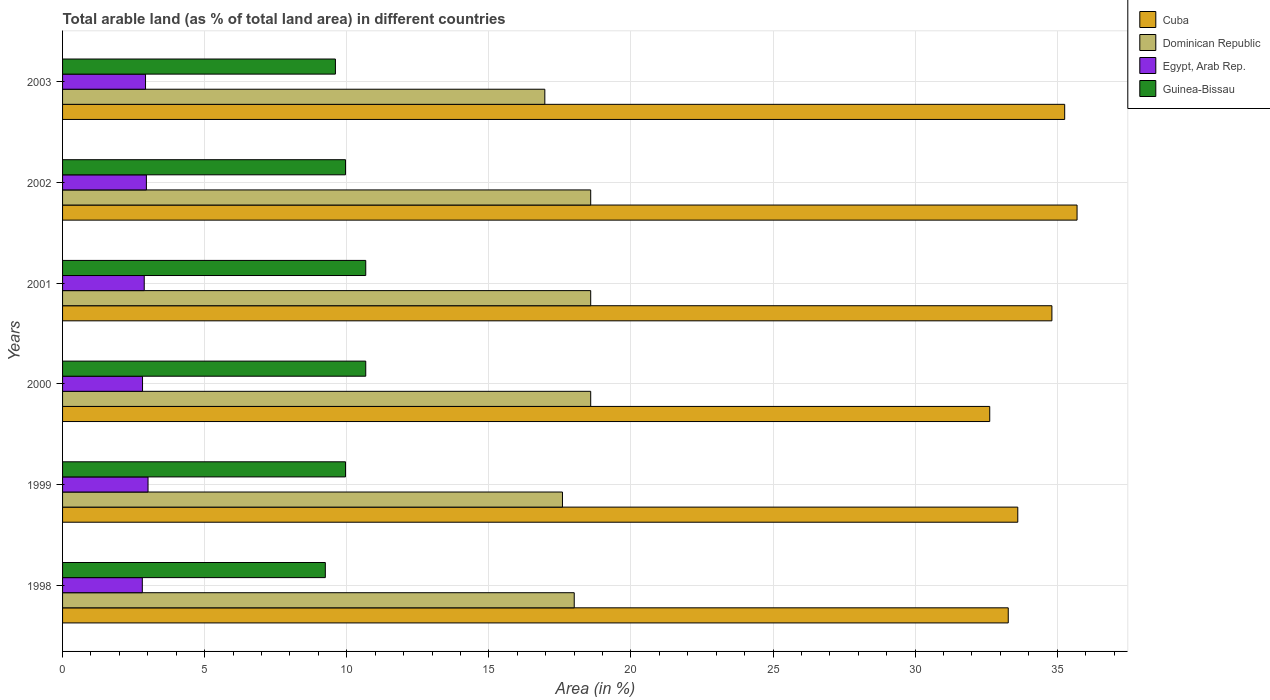Are the number of bars on each tick of the Y-axis equal?
Your answer should be compact. Yes. In how many cases, is the number of bars for a given year not equal to the number of legend labels?
Give a very brief answer. 0. What is the percentage of arable land in Guinea-Bissau in 1999?
Your answer should be compact. 9.96. Across all years, what is the maximum percentage of arable land in Egypt, Arab Rep.?
Offer a very short reply. 3.01. Across all years, what is the minimum percentage of arable land in Cuba?
Make the answer very short. 32.63. In which year was the percentage of arable land in Egypt, Arab Rep. maximum?
Give a very brief answer. 1999. What is the total percentage of arable land in Guinea-Bissau in the graph?
Your response must be concise. 60.1. What is the difference between the percentage of arable land in Dominican Republic in 2001 and that in 2003?
Make the answer very short. 1.61. What is the difference between the percentage of arable land in Egypt, Arab Rep. in 1998 and the percentage of arable land in Dominican Republic in 1999?
Give a very brief answer. -14.78. What is the average percentage of arable land in Dominican Republic per year?
Offer a terse response. 18.05. In the year 2002, what is the difference between the percentage of arable land in Egypt, Arab Rep. and percentage of arable land in Cuba?
Ensure brevity in your answer.  -32.75. What is the ratio of the percentage of arable land in Dominican Republic in 1998 to that in 2002?
Give a very brief answer. 0.97. Is the percentage of arable land in Dominican Republic in 1998 less than that in 2000?
Give a very brief answer. Yes. Is the difference between the percentage of arable land in Egypt, Arab Rep. in 1999 and 2001 greater than the difference between the percentage of arable land in Cuba in 1999 and 2001?
Provide a short and direct response. Yes. What is the difference between the highest and the lowest percentage of arable land in Guinea-Bissau?
Give a very brief answer. 1.42. In how many years, is the percentage of arable land in Egypt, Arab Rep. greater than the average percentage of arable land in Egypt, Arab Rep. taken over all years?
Offer a terse response. 3. Is the sum of the percentage of arable land in Dominican Republic in 2001 and 2002 greater than the maximum percentage of arable land in Egypt, Arab Rep. across all years?
Give a very brief answer. Yes. Is it the case that in every year, the sum of the percentage of arable land in Dominican Republic and percentage of arable land in Guinea-Bissau is greater than the sum of percentage of arable land in Egypt, Arab Rep. and percentage of arable land in Cuba?
Offer a very short reply. No. What does the 1st bar from the top in 1998 represents?
Provide a short and direct response. Guinea-Bissau. What does the 2nd bar from the bottom in 2000 represents?
Provide a succinct answer. Dominican Republic. Is it the case that in every year, the sum of the percentage of arable land in Egypt, Arab Rep. and percentage of arable land in Cuba is greater than the percentage of arable land in Guinea-Bissau?
Give a very brief answer. Yes. Are all the bars in the graph horizontal?
Keep it short and to the point. Yes. Where does the legend appear in the graph?
Make the answer very short. Top right. How many legend labels are there?
Provide a succinct answer. 4. How are the legend labels stacked?
Give a very brief answer. Vertical. What is the title of the graph?
Your response must be concise. Total arable land (as % of total land area) in different countries. Does "Central Europe" appear as one of the legend labels in the graph?
Give a very brief answer. No. What is the label or title of the X-axis?
Your answer should be very brief. Area (in %). What is the label or title of the Y-axis?
Give a very brief answer. Years. What is the Area (in %) of Cuba in 1998?
Offer a very short reply. 33.28. What is the Area (in %) in Dominican Republic in 1998?
Keep it short and to the point. 18. What is the Area (in %) in Egypt, Arab Rep. in 1998?
Keep it short and to the point. 2.81. What is the Area (in %) in Guinea-Bissau in 1998?
Provide a succinct answer. 9.25. What is the Area (in %) in Cuba in 1999?
Give a very brief answer. 33.61. What is the Area (in %) in Dominican Republic in 1999?
Provide a succinct answer. 17.59. What is the Area (in %) in Egypt, Arab Rep. in 1999?
Your answer should be very brief. 3.01. What is the Area (in %) in Guinea-Bissau in 1999?
Your response must be concise. 9.96. What is the Area (in %) of Cuba in 2000?
Give a very brief answer. 32.63. What is the Area (in %) of Dominican Republic in 2000?
Keep it short and to the point. 18.58. What is the Area (in %) in Egypt, Arab Rep. in 2000?
Provide a short and direct response. 2.81. What is the Area (in %) in Guinea-Bissau in 2000?
Your answer should be compact. 10.67. What is the Area (in %) of Cuba in 2001?
Offer a terse response. 34.81. What is the Area (in %) of Dominican Republic in 2001?
Offer a terse response. 18.58. What is the Area (in %) in Egypt, Arab Rep. in 2001?
Your answer should be compact. 2.87. What is the Area (in %) of Guinea-Bissau in 2001?
Make the answer very short. 10.67. What is the Area (in %) in Cuba in 2002?
Your answer should be compact. 35.7. What is the Area (in %) in Dominican Republic in 2002?
Give a very brief answer. 18.58. What is the Area (in %) in Egypt, Arab Rep. in 2002?
Provide a short and direct response. 2.95. What is the Area (in %) of Guinea-Bissau in 2002?
Make the answer very short. 9.96. What is the Area (in %) in Cuba in 2003?
Make the answer very short. 35.26. What is the Area (in %) of Dominican Republic in 2003?
Make the answer very short. 16.97. What is the Area (in %) in Egypt, Arab Rep. in 2003?
Offer a terse response. 2.92. What is the Area (in %) of Guinea-Bissau in 2003?
Your answer should be compact. 9.6. Across all years, what is the maximum Area (in %) of Cuba?
Your answer should be compact. 35.7. Across all years, what is the maximum Area (in %) of Dominican Republic?
Make the answer very short. 18.58. Across all years, what is the maximum Area (in %) of Egypt, Arab Rep.?
Your answer should be very brief. 3.01. Across all years, what is the maximum Area (in %) in Guinea-Bissau?
Ensure brevity in your answer.  10.67. Across all years, what is the minimum Area (in %) in Cuba?
Give a very brief answer. 32.63. Across all years, what is the minimum Area (in %) in Dominican Republic?
Your response must be concise. 16.97. Across all years, what is the minimum Area (in %) in Egypt, Arab Rep.?
Give a very brief answer. 2.81. Across all years, what is the minimum Area (in %) in Guinea-Bissau?
Your answer should be compact. 9.25. What is the total Area (in %) in Cuba in the graph?
Provide a succinct answer. 205.29. What is the total Area (in %) of Dominican Republic in the graph?
Keep it short and to the point. 108.32. What is the total Area (in %) of Egypt, Arab Rep. in the graph?
Your answer should be compact. 17.37. What is the total Area (in %) of Guinea-Bissau in the graph?
Give a very brief answer. 60.1. What is the difference between the Area (in %) of Cuba in 1998 and that in 1999?
Make the answer very short. -0.34. What is the difference between the Area (in %) in Dominican Republic in 1998 and that in 1999?
Keep it short and to the point. 0.41. What is the difference between the Area (in %) of Egypt, Arab Rep. in 1998 and that in 1999?
Keep it short and to the point. -0.2. What is the difference between the Area (in %) of Guinea-Bissau in 1998 and that in 1999?
Keep it short and to the point. -0.71. What is the difference between the Area (in %) in Cuba in 1998 and that in 2000?
Your response must be concise. 0.65. What is the difference between the Area (in %) in Dominican Republic in 1998 and that in 2000?
Offer a terse response. -0.58. What is the difference between the Area (in %) of Egypt, Arab Rep. in 1998 and that in 2000?
Ensure brevity in your answer.  -0.01. What is the difference between the Area (in %) in Guinea-Bissau in 1998 and that in 2000?
Offer a terse response. -1.42. What is the difference between the Area (in %) of Cuba in 1998 and that in 2001?
Offer a very short reply. -1.54. What is the difference between the Area (in %) of Dominican Republic in 1998 and that in 2001?
Offer a very short reply. -0.58. What is the difference between the Area (in %) in Egypt, Arab Rep. in 1998 and that in 2001?
Ensure brevity in your answer.  -0.07. What is the difference between the Area (in %) of Guinea-Bissau in 1998 and that in 2001?
Make the answer very short. -1.42. What is the difference between the Area (in %) in Cuba in 1998 and that in 2002?
Give a very brief answer. -2.42. What is the difference between the Area (in %) in Dominican Republic in 1998 and that in 2002?
Provide a succinct answer. -0.58. What is the difference between the Area (in %) in Egypt, Arab Rep. in 1998 and that in 2002?
Give a very brief answer. -0.14. What is the difference between the Area (in %) in Guinea-Bissau in 1998 and that in 2002?
Your answer should be compact. -0.71. What is the difference between the Area (in %) of Cuba in 1998 and that in 2003?
Ensure brevity in your answer.  -1.99. What is the difference between the Area (in %) in Dominican Republic in 1998 and that in 2003?
Give a very brief answer. 1.03. What is the difference between the Area (in %) of Egypt, Arab Rep. in 1998 and that in 2003?
Offer a terse response. -0.11. What is the difference between the Area (in %) in Guinea-Bissau in 1998 and that in 2003?
Ensure brevity in your answer.  -0.36. What is the difference between the Area (in %) of Cuba in 1999 and that in 2000?
Ensure brevity in your answer.  0.99. What is the difference between the Area (in %) in Dominican Republic in 1999 and that in 2000?
Your response must be concise. -0.99. What is the difference between the Area (in %) of Egypt, Arab Rep. in 1999 and that in 2000?
Offer a very short reply. 0.19. What is the difference between the Area (in %) in Guinea-Bissau in 1999 and that in 2000?
Offer a very short reply. -0.71. What is the difference between the Area (in %) in Cuba in 1999 and that in 2001?
Ensure brevity in your answer.  -1.2. What is the difference between the Area (in %) in Dominican Republic in 1999 and that in 2001?
Your answer should be very brief. -0.99. What is the difference between the Area (in %) in Egypt, Arab Rep. in 1999 and that in 2001?
Offer a terse response. 0.13. What is the difference between the Area (in %) in Guinea-Bissau in 1999 and that in 2001?
Keep it short and to the point. -0.71. What is the difference between the Area (in %) of Cuba in 1999 and that in 2002?
Keep it short and to the point. -2.09. What is the difference between the Area (in %) in Dominican Republic in 1999 and that in 2002?
Offer a terse response. -0.99. What is the difference between the Area (in %) in Egypt, Arab Rep. in 1999 and that in 2002?
Offer a very short reply. 0.06. What is the difference between the Area (in %) of Guinea-Bissau in 1999 and that in 2002?
Your answer should be compact. 0. What is the difference between the Area (in %) of Cuba in 1999 and that in 2003?
Provide a short and direct response. -1.65. What is the difference between the Area (in %) of Dominican Republic in 1999 and that in 2003?
Provide a succinct answer. 0.62. What is the difference between the Area (in %) in Egypt, Arab Rep. in 1999 and that in 2003?
Offer a terse response. 0.09. What is the difference between the Area (in %) in Guinea-Bissau in 1999 and that in 2003?
Give a very brief answer. 0.36. What is the difference between the Area (in %) of Cuba in 2000 and that in 2001?
Make the answer very short. -2.19. What is the difference between the Area (in %) of Dominican Republic in 2000 and that in 2001?
Your response must be concise. 0. What is the difference between the Area (in %) of Egypt, Arab Rep. in 2000 and that in 2001?
Ensure brevity in your answer.  -0.06. What is the difference between the Area (in %) of Guinea-Bissau in 2000 and that in 2001?
Make the answer very short. 0. What is the difference between the Area (in %) in Cuba in 2000 and that in 2002?
Keep it short and to the point. -3.07. What is the difference between the Area (in %) in Egypt, Arab Rep. in 2000 and that in 2002?
Give a very brief answer. -0.14. What is the difference between the Area (in %) in Guinea-Bissau in 2000 and that in 2002?
Provide a succinct answer. 0.71. What is the difference between the Area (in %) in Cuba in 2000 and that in 2003?
Your answer should be very brief. -2.64. What is the difference between the Area (in %) of Dominican Republic in 2000 and that in 2003?
Your answer should be very brief. 1.61. What is the difference between the Area (in %) of Egypt, Arab Rep. in 2000 and that in 2003?
Keep it short and to the point. -0.11. What is the difference between the Area (in %) of Guinea-Bissau in 2000 and that in 2003?
Offer a terse response. 1.07. What is the difference between the Area (in %) of Cuba in 2001 and that in 2002?
Provide a succinct answer. -0.89. What is the difference between the Area (in %) in Egypt, Arab Rep. in 2001 and that in 2002?
Offer a very short reply. -0.08. What is the difference between the Area (in %) of Guinea-Bissau in 2001 and that in 2002?
Your answer should be compact. 0.71. What is the difference between the Area (in %) of Cuba in 2001 and that in 2003?
Provide a succinct answer. -0.45. What is the difference between the Area (in %) of Dominican Republic in 2001 and that in 2003?
Your response must be concise. 1.61. What is the difference between the Area (in %) in Egypt, Arab Rep. in 2001 and that in 2003?
Offer a very short reply. -0.05. What is the difference between the Area (in %) in Guinea-Bissau in 2001 and that in 2003?
Your answer should be very brief. 1.07. What is the difference between the Area (in %) of Cuba in 2002 and that in 2003?
Keep it short and to the point. 0.44. What is the difference between the Area (in %) of Dominican Republic in 2002 and that in 2003?
Make the answer very short. 1.61. What is the difference between the Area (in %) of Egypt, Arab Rep. in 2002 and that in 2003?
Make the answer very short. 0.03. What is the difference between the Area (in %) in Guinea-Bissau in 2002 and that in 2003?
Ensure brevity in your answer.  0.36. What is the difference between the Area (in %) of Cuba in 1998 and the Area (in %) of Dominican Republic in 1999?
Ensure brevity in your answer.  15.69. What is the difference between the Area (in %) of Cuba in 1998 and the Area (in %) of Egypt, Arab Rep. in 1999?
Provide a succinct answer. 30.27. What is the difference between the Area (in %) of Cuba in 1998 and the Area (in %) of Guinea-Bissau in 1999?
Make the answer very short. 23.32. What is the difference between the Area (in %) in Dominican Republic in 1998 and the Area (in %) in Egypt, Arab Rep. in 1999?
Offer a terse response. 15. What is the difference between the Area (in %) in Dominican Republic in 1998 and the Area (in %) in Guinea-Bissau in 1999?
Offer a terse response. 8.05. What is the difference between the Area (in %) in Egypt, Arab Rep. in 1998 and the Area (in %) in Guinea-Bissau in 1999?
Ensure brevity in your answer.  -7.15. What is the difference between the Area (in %) of Cuba in 1998 and the Area (in %) of Dominican Republic in 2000?
Offer a terse response. 14.69. What is the difference between the Area (in %) of Cuba in 1998 and the Area (in %) of Egypt, Arab Rep. in 2000?
Your answer should be compact. 30.46. What is the difference between the Area (in %) in Cuba in 1998 and the Area (in %) in Guinea-Bissau in 2000?
Provide a succinct answer. 22.61. What is the difference between the Area (in %) of Dominican Republic in 1998 and the Area (in %) of Egypt, Arab Rep. in 2000?
Ensure brevity in your answer.  15.19. What is the difference between the Area (in %) of Dominican Republic in 1998 and the Area (in %) of Guinea-Bissau in 2000?
Make the answer very short. 7.34. What is the difference between the Area (in %) in Egypt, Arab Rep. in 1998 and the Area (in %) in Guinea-Bissau in 2000?
Provide a short and direct response. -7.86. What is the difference between the Area (in %) in Cuba in 1998 and the Area (in %) in Dominican Republic in 2001?
Offer a terse response. 14.69. What is the difference between the Area (in %) in Cuba in 1998 and the Area (in %) in Egypt, Arab Rep. in 2001?
Offer a terse response. 30.4. What is the difference between the Area (in %) in Cuba in 1998 and the Area (in %) in Guinea-Bissau in 2001?
Provide a short and direct response. 22.61. What is the difference between the Area (in %) in Dominican Republic in 1998 and the Area (in %) in Egypt, Arab Rep. in 2001?
Make the answer very short. 15.13. What is the difference between the Area (in %) in Dominican Republic in 1998 and the Area (in %) in Guinea-Bissau in 2001?
Give a very brief answer. 7.34. What is the difference between the Area (in %) of Egypt, Arab Rep. in 1998 and the Area (in %) of Guinea-Bissau in 2001?
Provide a succinct answer. -7.86. What is the difference between the Area (in %) of Cuba in 1998 and the Area (in %) of Dominican Republic in 2002?
Give a very brief answer. 14.69. What is the difference between the Area (in %) of Cuba in 1998 and the Area (in %) of Egypt, Arab Rep. in 2002?
Your answer should be compact. 30.33. What is the difference between the Area (in %) in Cuba in 1998 and the Area (in %) in Guinea-Bissau in 2002?
Your answer should be compact. 23.32. What is the difference between the Area (in %) of Dominican Republic in 1998 and the Area (in %) of Egypt, Arab Rep. in 2002?
Ensure brevity in your answer.  15.06. What is the difference between the Area (in %) in Dominican Republic in 1998 and the Area (in %) in Guinea-Bissau in 2002?
Make the answer very short. 8.05. What is the difference between the Area (in %) of Egypt, Arab Rep. in 1998 and the Area (in %) of Guinea-Bissau in 2002?
Give a very brief answer. -7.15. What is the difference between the Area (in %) in Cuba in 1998 and the Area (in %) in Dominican Republic in 2003?
Keep it short and to the point. 16.31. What is the difference between the Area (in %) of Cuba in 1998 and the Area (in %) of Egypt, Arab Rep. in 2003?
Keep it short and to the point. 30.36. What is the difference between the Area (in %) in Cuba in 1998 and the Area (in %) in Guinea-Bissau in 2003?
Offer a terse response. 23.68. What is the difference between the Area (in %) of Dominican Republic in 1998 and the Area (in %) of Egypt, Arab Rep. in 2003?
Your response must be concise. 15.09. What is the difference between the Area (in %) of Dominican Republic in 1998 and the Area (in %) of Guinea-Bissau in 2003?
Offer a terse response. 8.4. What is the difference between the Area (in %) in Egypt, Arab Rep. in 1998 and the Area (in %) in Guinea-Bissau in 2003?
Make the answer very short. -6.8. What is the difference between the Area (in %) of Cuba in 1999 and the Area (in %) of Dominican Republic in 2000?
Make the answer very short. 15.03. What is the difference between the Area (in %) of Cuba in 1999 and the Area (in %) of Egypt, Arab Rep. in 2000?
Your answer should be compact. 30.8. What is the difference between the Area (in %) of Cuba in 1999 and the Area (in %) of Guinea-Bissau in 2000?
Give a very brief answer. 22.94. What is the difference between the Area (in %) in Dominican Republic in 1999 and the Area (in %) in Egypt, Arab Rep. in 2000?
Make the answer very short. 14.78. What is the difference between the Area (in %) of Dominican Republic in 1999 and the Area (in %) of Guinea-Bissau in 2000?
Your answer should be very brief. 6.92. What is the difference between the Area (in %) of Egypt, Arab Rep. in 1999 and the Area (in %) of Guinea-Bissau in 2000?
Your response must be concise. -7.66. What is the difference between the Area (in %) in Cuba in 1999 and the Area (in %) in Dominican Republic in 2001?
Your response must be concise. 15.03. What is the difference between the Area (in %) in Cuba in 1999 and the Area (in %) in Egypt, Arab Rep. in 2001?
Your answer should be very brief. 30.74. What is the difference between the Area (in %) of Cuba in 1999 and the Area (in %) of Guinea-Bissau in 2001?
Your answer should be compact. 22.94. What is the difference between the Area (in %) of Dominican Republic in 1999 and the Area (in %) of Egypt, Arab Rep. in 2001?
Your answer should be compact. 14.72. What is the difference between the Area (in %) of Dominican Republic in 1999 and the Area (in %) of Guinea-Bissau in 2001?
Your answer should be very brief. 6.92. What is the difference between the Area (in %) of Egypt, Arab Rep. in 1999 and the Area (in %) of Guinea-Bissau in 2001?
Give a very brief answer. -7.66. What is the difference between the Area (in %) in Cuba in 1999 and the Area (in %) in Dominican Republic in 2002?
Ensure brevity in your answer.  15.03. What is the difference between the Area (in %) in Cuba in 1999 and the Area (in %) in Egypt, Arab Rep. in 2002?
Offer a very short reply. 30.66. What is the difference between the Area (in %) in Cuba in 1999 and the Area (in %) in Guinea-Bissau in 2002?
Your response must be concise. 23.66. What is the difference between the Area (in %) in Dominican Republic in 1999 and the Area (in %) in Egypt, Arab Rep. in 2002?
Make the answer very short. 14.64. What is the difference between the Area (in %) of Dominican Republic in 1999 and the Area (in %) of Guinea-Bissau in 2002?
Make the answer very short. 7.63. What is the difference between the Area (in %) of Egypt, Arab Rep. in 1999 and the Area (in %) of Guinea-Bissau in 2002?
Provide a succinct answer. -6.95. What is the difference between the Area (in %) of Cuba in 1999 and the Area (in %) of Dominican Republic in 2003?
Provide a short and direct response. 16.64. What is the difference between the Area (in %) of Cuba in 1999 and the Area (in %) of Egypt, Arab Rep. in 2003?
Your answer should be compact. 30.69. What is the difference between the Area (in %) of Cuba in 1999 and the Area (in %) of Guinea-Bissau in 2003?
Provide a succinct answer. 24.01. What is the difference between the Area (in %) in Dominican Republic in 1999 and the Area (in %) in Egypt, Arab Rep. in 2003?
Your answer should be compact. 14.67. What is the difference between the Area (in %) of Dominican Republic in 1999 and the Area (in %) of Guinea-Bissau in 2003?
Ensure brevity in your answer.  7.99. What is the difference between the Area (in %) of Egypt, Arab Rep. in 1999 and the Area (in %) of Guinea-Bissau in 2003?
Make the answer very short. -6.59. What is the difference between the Area (in %) of Cuba in 2000 and the Area (in %) of Dominican Republic in 2001?
Offer a very short reply. 14.04. What is the difference between the Area (in %) of Cuba in 2000 and the Area (in %) of Egypt, Arab Rep. in 2001?
Offer a very short reply. 29.75. What is the difference between the Area (in %) of Cuba in 2000 and the Area (in %) of Guinea-Bissau in 2001?
Offer a terse response. 21.96. What is the difference between the Area (in %) of Dominican Republic in 2000 and the Area (in %) of Egypt, Arab Rep. in 2001?
Keep it short and to the point. 15.71. What is the difference between the Area (in %) in Dominican Republic in 2000 and the Area (in %) in Guinea-Bissau in 2001?
Your response must be concise. 7.92. What is the difference between the Area (in %) in Egypt, Arab Rep. in 2000 and the Area (in %) in Guinea-Bissau in 2001?
Your response must be concise. -7.85. What is the difference between the Area (in %) in Cuba in 2000 and the Area (in %) in Dominican Republic in 2002?
Provide a succinct answer. 14.04. What is the difference between the Area (in %) in Cuba in 2000 and the Area (in %) in Egypt, Arab Rep. in 2002?
Your answer should be compact. 29.68. What is the difference between the Area (in %) in Cuba in 2000 and the Area (in %) in Guinea-Bissau in 2002?
Provide a short and direct response. 22.67. What is the difference between the Area (in %) of Dominican Republic in 2000 and the Area (in %) of Egypt, Arab Rep. in 2002?
Provide a succinct answer. 15.63. What is the difference between the Area (in %) in Dominican Republic in 2000 and the Area (in %) in Guinea-Bissau in 2002?
Keep it short and to the point. 8.63. What is the difference between the Area (in %) of Egypt, Arab Rep. in 2000 and the Area (in %) of Guinea-Bissau in 2002?
Give a very brief answer. -7.14. What is the difference between the Area (in %) of Cuba in 2000 and the Area (in %) of Dominican Republic in 2003?
Offer a very short reply. 15.66. What is the difference between the Area (in %) in Cuba in 2000 and the Area (in %) in Egypt, Arab Rep. in 2003?
Make the answer very short. 29.71. What is the difference between the Area (in %) in Cuba in 2000 and the Area (in %) in Guinea-Bissau in 2003?
Make the answer very short. 23.02. What is the difference between the Area (in %) of Dominican Republic in 2000 and the Area (in %) of Egypt, Arab Rep. in 2003?
Give a very brief answer. 15.67. What is the difference between the Area (in %) in Dominican Republic in 2000 and the Area (in %) in Guinea-Bissau in 2003?
Make the answer very short. 8.98. What is the difference between the Area (in %) of Egypt, Arab Rep. in 2000 and the Area (in %) of Guinea-Bissau in 2003?
Offer a very short reply. -6.79. What is the difference between the Area (in %) of Cuba in 2001 and the Area (in %) of Dominican Republic in 2002?
Your response must be concise. 16.23. What is the difference between the Area (in %) of Cuba in 2001 and the Area (in %) of Egypt, Arab Rep. in 2002?
Your answer should be very brief. 31.86. What is the difference between the Area (in %) in Cuba in 2001 and the Area (in %) in Guinea-Bissau in 2002?
Your response must be concise. 24.86. What is the difference between the Area (in %) in Dominican Republic in 2001 and the Area (in %) in Egypt, Arab Rep. in 2002?
Offer a very short reply. 15.63. What is the difference between the Area (in %) in Dominican Republic in 2001 and the Area (in %) in Guinea-Bissau in 2002?
Make the answer very short. 8.63. What is the difference between the Area (in %) of Egypt, Arab Rep. in 2001 and the Area (in %) of Guinea-Bissau in 2002?
Keep it short and to the point. -7.08. What is the difference between the Area (in %) in Cuba in 2001 and the Area (in %) in Dominican Republic in 2003?
Offer a very short reply. 17.84. What is the difference between the Area (in %) of Cuba in 2001 and the Area (in %) of Egypt, Arab Rep. in 2003?
Ensure brevity in your answer.  31.89. What is the difference between the Area (in %) in Cuba in 2001 and the Area (in %) in Guinea-Bissau in 2003?
Offer a very short reply. 25.21. What is the difference between the Area (in %) of Dominican Republic in 2001 and the Area (in %) of Egypt, Arab Rep. in 2003?
Your response must be concise. 15.67. What is the difference between the Area (in %) of Dominican Republic in 2001 and the Area (in %) of Guinea-Bissau in 2003?
Your answer should be very brief. 8.98. What is the difference between the Area (in %) of Egypt, Arab Rep. in 2001 and the Area (in %) of Guinea-Bissau in 2003?
Offer a very short reply. -6.73. What is the difference between the Area (in %) of Cuba in 2002 and the Area (in %) of Dominican Republic in 2003?
Your answer should be compact. 18.73. What is the difference between the Area (in %) in Cuba in 2002 and the Area (in %) in Egypt, Arab Rep. in 2003?
Provide a succinct answer. 32.78. What is the difference between the Area (in %) in Cuba in 2002 and the Area (in %) in Guinea-Bissau in 2003?
Provide a succinct answer. 26.1. What is the difference between the Area (in %) of Dominican Republic in 2002 and the Area (in %) of Egypt, Arab Rep. in 2003?
Your answer should be very brief. 15.67. What is the difference between the Area (in %) of Dominican Republic in 2002 and the Area (in %) of Guinea-Bissau in 2003?
Make the answer very short. 8.98. What is the difference between the Area (in %) of Egypt, Arab Rep. in 2002 and the Area (in %) of Guinea-Bissau in 2003?
Offer a terse response. -6.65. What is the average Area (in %) in Cuba per year?
Give a very brief answer. 34.22. What is the average Area (in %) of Dominican Republic per year?
Provide a succinct answer. 18.05. What is the average Area (in %) in Egypt, Arab Rep. per year?
Keep it short and to the point. 2.9. What is the average Area (in %) in Guinea-Bissau per year?
Offer a very short reply. 10.02. In the year 1998, what is the difference between the Area (in %) in Cuba and Area (in %) in Dominican Republic?
Your answer should be very brief. 15.27. In the year 1998, what is the difference between the Area (in %) in Cuba and Area (in %) in Egypt, Arab Rep.?
Offer a terse response. 30.47. In the year 1998, what is the difference between the Area (in %) of Cuba and Area (in %) of Guinea-Bissau?
Your response must be concise. 24.03. In the year 1998, what is the difference between the Area (in %) of Dominican Republic and Area (in %) of Egypt, Arab Rep.?
Keep it short and to the point. 15.2. In the year 1998, what is the difference between the Area (in %) in Dominican Republic and Area (in %) in Guinea-Bissau?
Ensure brevity in your answer.  8.76. In the year 1998, what is the difference between the Area (in %) in Egypt, Arab Rep. and Area (in %) in Guinea-Bissau?
Provide a short and direct response. -6.44. In the year 1999, what is the difference between the Area (in %) in Cuba and Area (in %) in Dominican Republic?
Your answer should be compact. 16.02. In the year 1999, what is the difference between the Area (in %) in Cuba and Area (in %) in Egypt, Arab Rep.?
Give a very brief answer. 30.61. In the year 1999, what is the difference between the Area (in %) of Cuba and Area (in %) of Guinea-Bissau?
Give a very brief answer. 23.66. In the year 1999, what is the difference between the Area (in %) in Dominican Republic and Area (in %) in Egypt, Arab Rep.?
Offer a terse response. 14.58. In the year 1999, what is the difference between the Area (in %) of Dominican Republic and Area (in %) of Guinea-Bissau?
Offer a terse response. 7.63. In the year 1999, what is the difference between the Area (in %) in Egypt, Arab Rep. and Area (in %) in Guinea-Bissau?
Make the answer very short. -6.95. In the year 2000, what is the difference between the Area (in %) of Cuba and Area (in %) of Dominican Republic?
Offer a very short reply. 14.04. In the year 2000, what is the difference between the Area (in %) in Cuba and Area (in %) in Egypt, Arab Rep.?
Provide a succinct answer. 29.81. In the year 2000, what is the difference between the Area (in %) of Cuba and Area (in %) of Guinea-Bissau?
Make the answer very short. 21.96. In the year 2000, what is the difference between the Area (in %) in Dominican Republic and Area (in %) in Egypt, Arab Rep.?
Ensure brevity in your answer.  15.77. In the year 2000, what is the difference between the Area (in %) in Dominican Republic and Area (in %) in Guinea-Bissau?
Your answer should be compact. 7.92. In the year 2000, what is the difference between the Area (in %) in Egypt, Arab Rep. and Area (in %) in Guinea-Bissau?
Your answer should be very brief. -7.85. In the year 2001, what is the difference between the Area (in %) in Cuba and Area (in %) in Dominican Republic?
Your answer should be compact. 16.23. In the year 2001, what is the difference between the Area (in %) in Cuba and Area (in %) in Egypt, Arab Rep.?
Offer a terse response. 31.94. In the year 2001, what is the difference between the Area (in %) of Cuba and Area (in %) of Guinea-Bissau?
Ensure brevity in your answer.  24.15. In the year 2001, what is the difference between the Area (in %) of Dominican Republic and Area (in %) of Egypt, Arab Rep.?
Keep it short and to the point. 15.71. In the year 2001, what is the difference between the Area (in %) of Dominican Republic and Area (in %) of Guinea-Bissau?
Your response must be concise. 7.92. In the year 2001, what is the difference between the Area (in %) in Egypt, Arab Rep. and Area (in %) in Guinea-Bissau?
Keep it short and to the point. -7.79. In the year 2002, what is the difference between the Area (in %) in Cuba and Area (in %) in Dominican Republic?
Provide a short and direct response. 17.11. In the year 2002, what is the difference between the Area (in %) in Cuba and Area (in %) in Egypt, Arab Rep.?
Offer a terse response. 32.75. In the year 2002, what is the difference between the Area (in %) of Cuba and Area (in %) of Guinea-Bissau?
Your answer should be compact. 25.74. In the year 2002, what is the difference between the Area (in %) of Dominican Republic and Area (in %) of Egypt, Arab Rep.?
Make the answer very short. 15.63. In the year 2002, what is the difference between the Area (in %) in Dominican Republic and Area (in %) in Guinea-Bissau?
Provide a short and direct response. 8.63. In the year 2002, what is the difference between the Area (in %) in Egypt, Arab Rep. and Area (in %) in Guinea-Bissau?
Provide a short and direct response. -7.01. In the year 2003, what is the difference between the Area (in %) of Cuba and Area (in %) of Dominican Republic?
Ensure brevity in your answer.  18.29. In the year 2003, what is the difference between the Area (in %) in Cuba and Area (in %) in Egypt, Arab Rep.?
Offer a very short reply. 32.34. In the year 2003, what is the difference between the Area (in %) in Cuba and Area (in %) in Guinea-Bissau?
Make the answer very short. 25.66. In the year 2003, what is the difference between the Area (in %) of Dominican Republic and Area (in %) of Egypt, Arab Rep.?
Your answer should be very brief. 14.05. In the year 2003, what is the difference between the Area (in %) of Dominican Republic and Area (in %) of Guinea-Bissau?
Provide a short and direct response. 7.37. In the year 2003, what is the difference between the Area (in %) in Egypt, Arab Rep. and Area (in %) in Guinea-Bissau?
Make the answer very short. -6.68. What is the ratio of the Area (in %) of Cuba in 1998 to that in 1999?
Provide a short and direct response. 0.99. What is the ratio of the Area (in %) in Dominican Republic in 1998 to that in 1999?
Ensure brevity in your answer.  1.02. What is the ratio of the Area (in %) in Egypt, Arab Rep. in 1998 to that in 1999?
Keep it short and to the point. 0.93. What is the ratio of the Area (in %) in Guinea-Bissau in 1998 to that in 1999?
Offer a terse response. 0.93. What is the ratio of the Area (in %) in Cuba in 1998 to that in 2000?
Your answer should be compact. 1.02. What is the ratio of the Area (in %) of Dominican Republic in 1998 to that in 2000?
Your answer should be compact. 0.97. What is the ratio of the Area (in %) in Guinea-Bissau in 1998 to that in 2000?
Keep it short and to the point. 0.87. What is the ratio of the Area (in %) of Cuba in 1998 to that in 2001?
Offer a terse response. 0.96. What is the ratio of the Area (in %) in Dominican Republic in 1998 to that in 2001?
Your answer should be compact. 0.97. What is the ratio of the Area (in %) of Egypt, Arab Rep. in 1998 to that in 2001?
Your response must be concise. 0.98. What is the ratio of the Area (in %) in Guinea-Bissau in 1998 to that in 2001?
Your answer should be very brief. 0.87. What is the ratio of the Area (in %) in Cuba in 1998 to that in 2002?
Keep it short and to the point. 0.93. What is the ratio of the Area (in %) in Dominican Republic in 1998 to that in 2002?
Ensure brevity in your answer.  0.97. What is the ratio of the Area (in %) of Egypt, Arab Rep. in 1998 to that in 2002?
Give a very brief answer. 0.95. What is the ratio of the Area (in %) in Cuba in 1998 to that in 2003?
Your response must be concise. 0.94. What is the ratio of the Area (in %) in Dominican Republic in 1998 to that in 2003?
Make the answer very short. 1.06. What is the ratio of the Area (in %) of Egypt, Arab Rep. in 1998 to that in 2003?
Your answer should be compact. 0.96. What is the ratio of the Area (in %) of Cuba in 1999 to that in 2000?
Your answer should be very brief. 1.03. What is the ratio of the Area (in %) in Dominican Republic in 1999 to that in 2000?
Provide a short and direct response. 0.95. What is the ratio of the Area (in %) in Egypt, Arab Rep. in 1999 to that in 2000?
Keep it short and to the point. 1.07. What is the ratio of the Area (in %) in Cuba in 1999 to that in 2001?
Offer a terse response. 0.97. What is the ratio of the Area (in %) of Dominican Republic in 1999 to that in 2001?
Offer a very short reply. 0.95. What is the ratio of the Area (in %) of Egypt, Arab Rep. in 1999 to that in 2001?
Keep it short and to the point. 1.05. What is the ratio of the Area (in %) in Guinea-Bissau in 1999 to that in 2001?
Provide a short and direct response. 0.93. What is the ratio of the Area (in %) in Cuba in 1999 to that in 2002?
Keep it short and to the point. 0.94. What is the ratio of the Area (in %) in Dominican Republic in 1999 to that in 2002?
Make the answer very short. 0.95. What is the ratio of the Area (in %) in Egypt, Arab Rep. in 1999 to that in 2002?
Your answer should be very brief. 1.02. What is the ratio of the Area (in %) in Guinea-Bissau in 1999 to that in 2002?
Your answer should be compact. 1. What is the ratio of the Area (in %) in Cuba in 1999 to that in 2003?
Offer a very short reply. 0.95. What is the ratio of the Area (in %) in Dominican Republic in 1999 to that in 2003?
Give a very brief answer. 1.04. What is the ratio of the Area (in %) in Egypt, Arab Rep. in 1999 to that in 2003?
Your response must be concise. 1.03. What is the ratio of the Area (in %) of Cuba in 2000 to that in 2001?
Offer a very short reply. 0.94. What is the ratio of the Area (in %) in Cuba in 2000 to that in 2002?
Your answer should be very brief. 0.91. What is the ratio of the Area (in %) of Egypt, Arab Rep. in 2000 to that in 2002?
Make the answer very short. 0.95. What is the ratio of the Area (in %) of Guinea-Bissau in 2000 to that in 2002?
Your response must be concise. 1.07. What is the ratio of the Area (in %) of Cuba in 2000 to that in 2003?
Ensure brevity in your answer.  0.93. What is the ratio of the Area (in %) in Dominican Republic in 2000 to that in 2003?
Offer a terse response. 1.1. What is the ratio of the Area (in %) in Egypt, Arab Rep. in 2000 to that in 2003?
Your answer should be compact. 0.96. What is the ratio of the Area (in %) in Guinea-Bissau in 2000 to that in 2003?
Offer a terse response. 1.11. What is the ratio of the Area (in %) of Cuba in 2001 to that in 2002?
Keep it short and to the point. 0.98. What is the ratio of the Area (in %) in Egypt, Arab Rep. in 2001 to that in 2002?
Your response must be concise. 0.97. What is the ratio of the Area (in %) of Guinea-Bissau in 2001 to that in 2002?
Provide a short and direct response. 1.07. What is the ratio of the Area (in %) of Cuba in 2001 to that in 2003?
Ensure brevity in your answer.  0.99. What is the ratio of the Area (in %) in Dominican Republic in 2001 to that in 2003?
Make the answer very short. 1.1. What is the ratio of the Area (in %) of Egypt, Arab Rep. in 2001 to that in 2003?
Give a very brief answer. 0.98. What is the ratio of the Area (in %) of Guinea-Bissau in 2001 to that in 2003?
Provide a succinct answer. 1.11. What is the ratio of the Area (in %) of Cuba in 2002 to that in 2003?
Make the answer very short. 1.01. What is the ratio of the Area (in %) of Dominican Republic in 2002 to that in 2003?
Your answer should be very brief. 1.1. What is the ratio of the Area (in %) in Egypt, Arab Rep. in 2002 to that in 2003?
Provide a short and direct response. 1.01. What is the ratio of the Area (in %) of Guinea-Bissau in 2002 to that in 2003?
Your answer should be compact. 1.04. What is the difference between the highest and the second highest Area (in %) in Cuba?
Your answer should be very brief. 0.44. What is the difference between the highest and the second highest Area (in %) in Egypt, Arab Rep.?
Your answer should be compact. 0.06. What is the difference between the highest and the lowest Area (in %) of Cuba?
Give a very brief answer. 3.07. What is the difference between the highest and the lowest Area (in %) of Dominican Republic?
Offer a very short reply. 1.61. What is the difference between the highest and the lowest Area (in %) in Egypt, Arab Rep.?
Offer a terse response. 0.2. What is the difference between the highest and the lowest Area (in %) of Guinea-Bissau?
Offer a terse response. 1.42. 